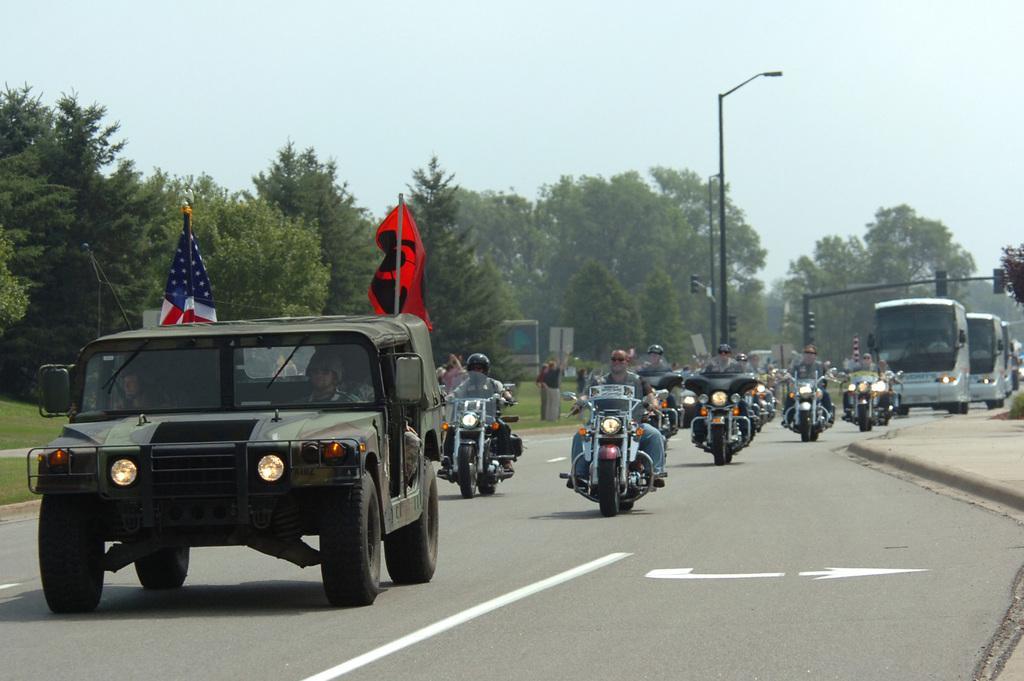Please provide a concise description of this image. As we can see in the image there is a jeep, flags, few people here and there, motorcycles, buses, street lamp, traffic signal, trees, grass and sky. 